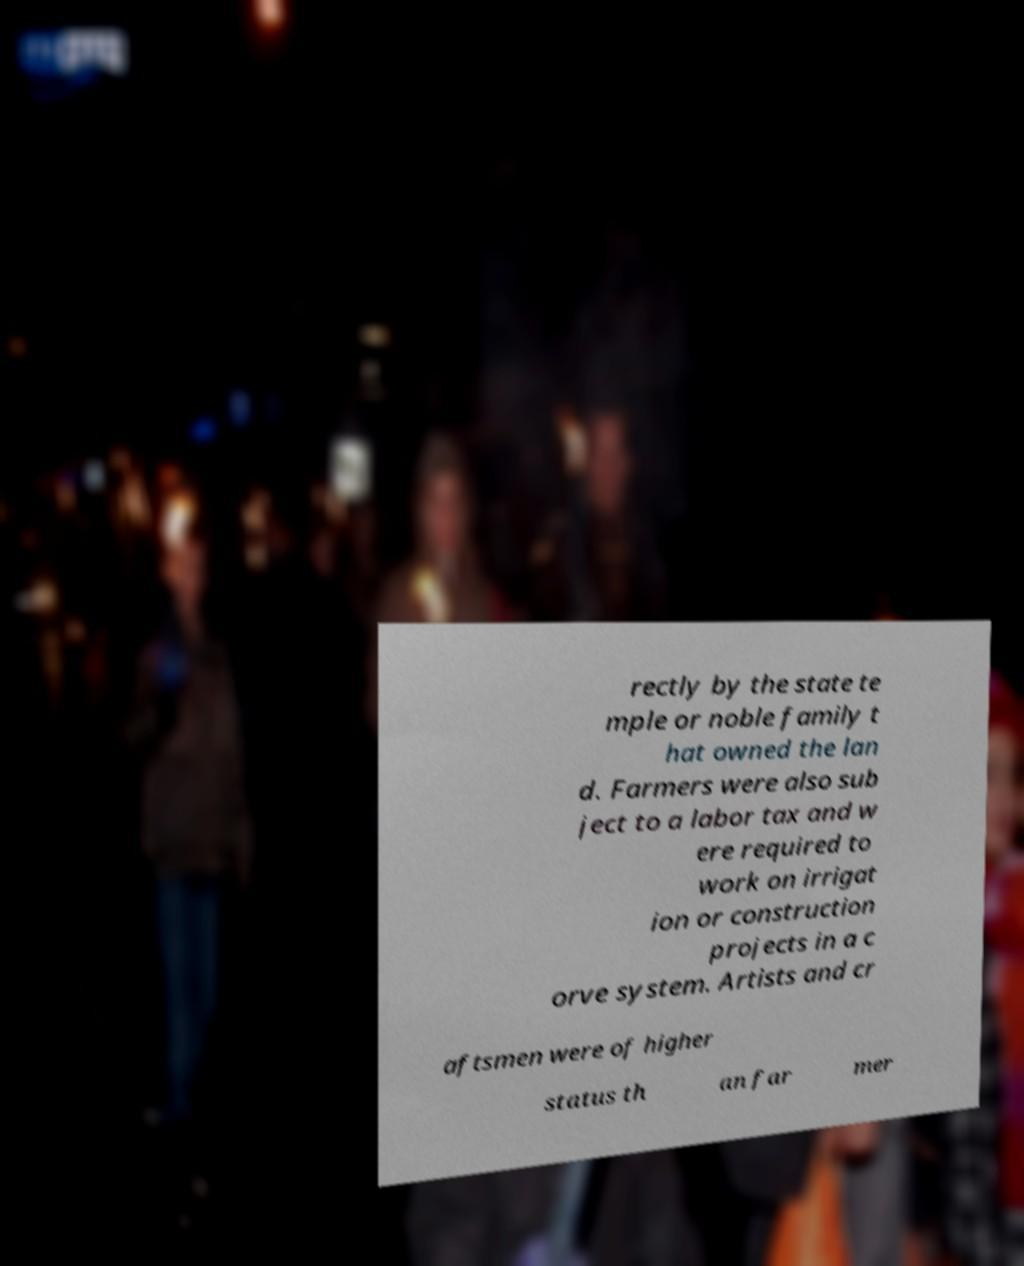I need the written content from this picture converted into text. Can you do that? rectly by the state te mple or noble family t hat owned the lan d. Farmers were also sub ject to a labor tax and w ere required to work on irrigat ion or construction projects in a c orve system. Artists and cr aftsmen were of higher status th an far mer 